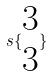Convert formula to latex. <formula><loc_0><loc_0><loc_500><loc_500>s \{ \begin{matrix} 3 \\ 3 \end{matrix} \}</formula> 